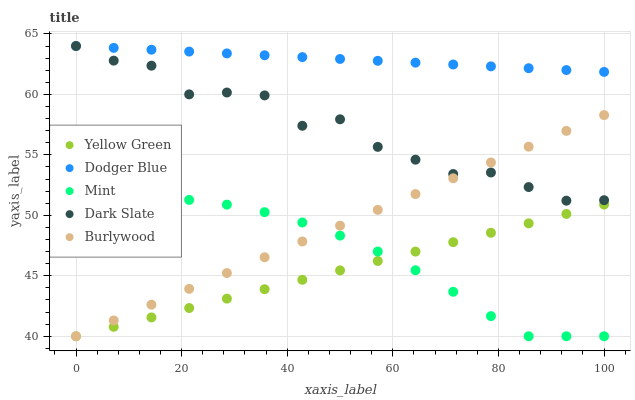Does Yellow Green have the minimum area under the curve?
Answer yes or no. Yes. Does Dodger Blue have the maximum area under the curve?
Answer yes or no. Yes. Does Mint have the minimum area under the curve?
Answer yes or no. No. Does Mint have the maximum area under the curve?
Answer yes or no. No. Is Dodger Blue the smoothest?
Answer yes or no. Yes. Is Dark Slate the roughest?
Answer yes or no. Yes. Is Mint the smoothest?
Answer yes or no. No. Is Mint the roughest?
Answer yes or no. No. Does Burlywood have the lowest value?
Answer yes or no. Yes. Does Dodger Blue have the lowest value?
Answer yes or no. No. Does Dark Slate have the highest value?
Answer yes or no. Yes. Does Mint have the highest value?
Answer yes or no. No. Is Burlywood less than Dodger Blue?
Answer yes or no. Yes. Is Dark Slate greater than Yellow Green?
Answer yes or no. Yes. Does Dark Slate intersect Dodger Blue?
Answer yes or no. Yes. Is Dark Slate less than Dodger Blue?
Answer yes or no. No. Is Dark Slate greater than Dodger Blue?
Answer yes or no. No. Does Burlywood intersect Dodger Blue?
Answer yes or no. No. 